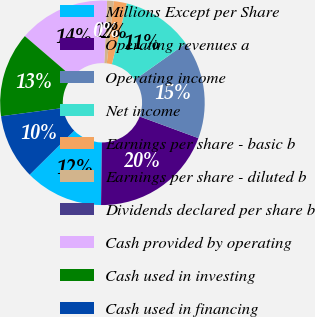<chart> <loc_0><loc_0><loc_500><loc_500><pie_chart><fcel>Millions Except per Share<fcel>Operating revenues a<fcel>Operating income<fcel>Net income<fcel>Earnings per share - basic b<fcel>Earnings per share - diluted b<fcel>Dividends declared per share b<fcel>Cash provided by operating<fcel>Cash used in investing<fcel>Cash used in financing<nl><fcel>12.37%<fcel>19.59%<fcel>15.46%<fcel>11.34%<fcel>2.06%<fcel>1.03%<fcel>0.0%<fcel>14.43%<fcel>13.4%<fcel>10.31%<nl></chart> 